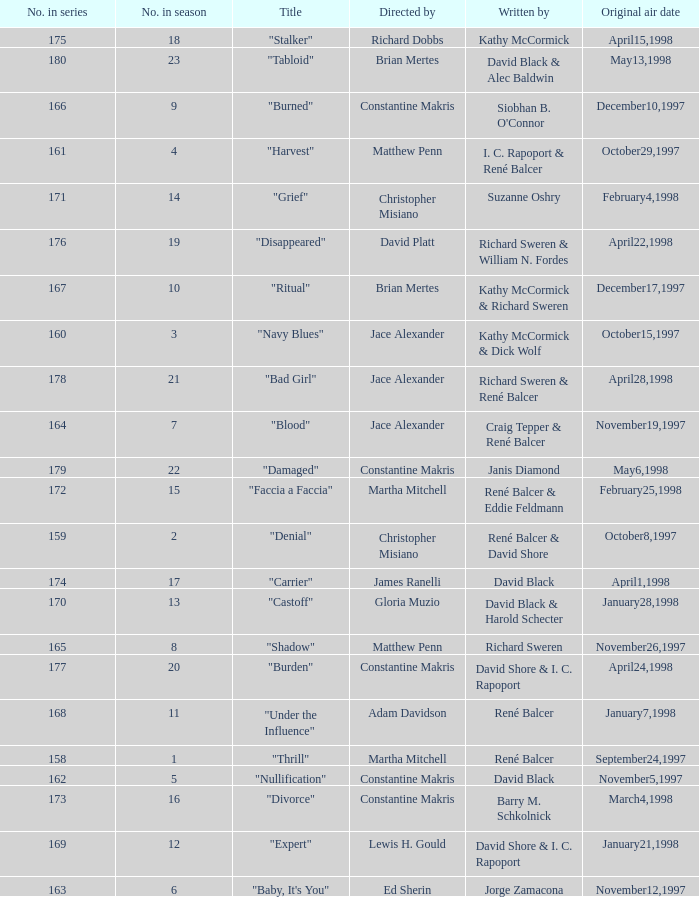The first episode in this season had what number in the series?  158.0. 